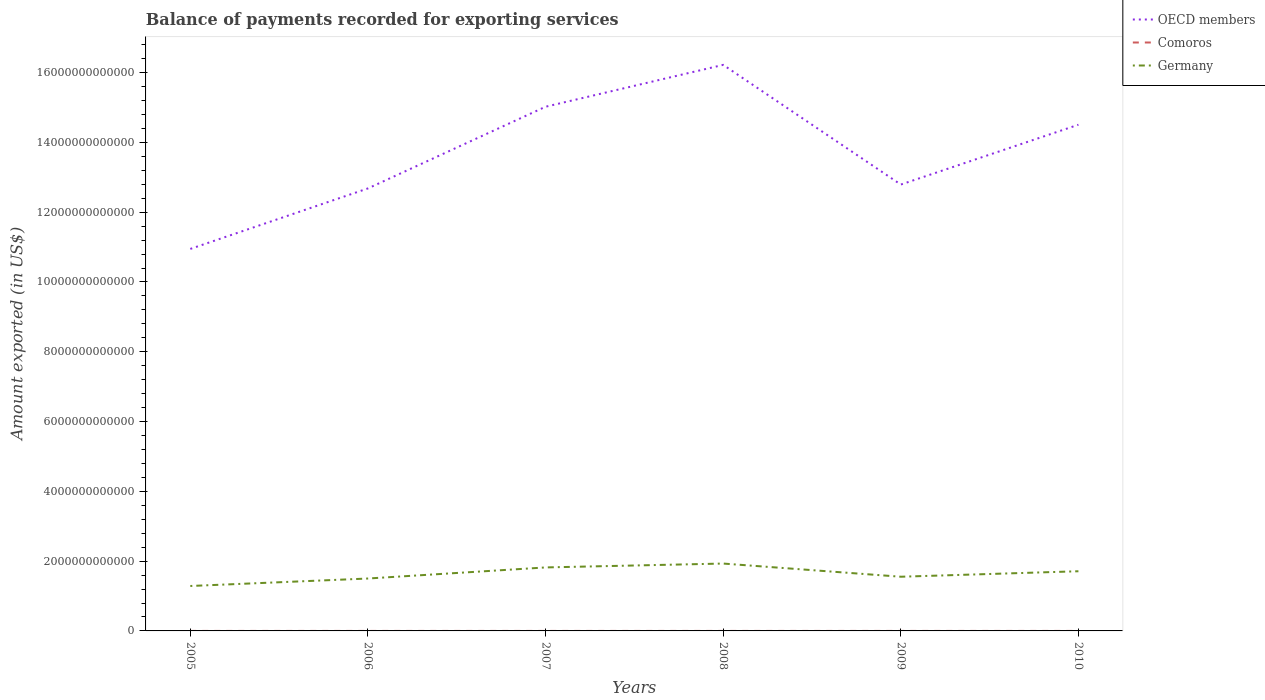How many different coloured lines are there?
Keep it short and to the point. 3. Across all years, what is the maximum amount exported in Comoros?
Offer a terse response. 5.95e+07. What is the total amount exported in Comoros in the graph?
Provide a short and direct response. -1.62e+07. What is the difference between the highest and the second highest amount exported in Comoros?
Your response must be concise. 3.11e+07. Is the amount exported in OECD members strictly greater than the amount exported in Comoros over the years?
Provide a succinct answer. No. How many lines are there?
Provide a short and direct response. 3. How many years are there in the graph?
Give a very brief answer. 6. What is the difference between two consecutive major ticks on the Y-axis?
Provide a succinct answer. 2.00e+12. Does the graph contain any zero values?
Keep it short and to the point. No. Does the graph contain grids?
Your answer should be compact. No. What is the title of the graph?
Provide a short and direct response. Balance of payments recorded for exporting services. Does "Kazakhstan" appear as one of the legend labels in the graph?
Provide a succinct answer. No. What is the label or title of the X-axis?
Your response must be concise. Years. What is the label or title of the Y-axis?
Offer a terse response. Amount exported (in US$). What is the Amount exported (in US$) of OECD members in 2005?
Your response must be concise. 1.09e+13. What is the Amount exported (in US$) in Comoros in 2005?
Ensure brevity in your answer.  5.95e+07. What is the Amount exported (in US$) in Germany in 2005?
Provide a succinct answer. 1.29e+12. What is the Amount exported (in US$) of OECD members in 2006?
Provide a short and direct response. 1.27e+13. What is the Amount exported (in US$) in Comoros in 2006?
Give a very brief answer. 6.35e+07. What is the Amount exported (in US$) in Germany in 2006?
Your answer should be compact. 1.50e+12. What is the Amount exported (in US$) in OECD members in 2007?
Make the answer very short. 1.50e+13. What is the Amount exported (in US$) in Comoros in 2007?
Give a very brief answer. 7.68e+07. What is the Amount exported (in US$) of Germany in 2007?
Offer a terse response. 1.82e+12. What is the Amount exported (in US$) of OECD members in 2008?
Offer a terse response. 1.62e+13. What is the Amount exported (in US$) of Comoros in 2008?
Your answer should be compact. 7.97e+07. What is the Amount exported (in US$) in Germany in 2008?
Give a very brief answer. 1.93e+12. What is the Amount exported (in US$) in OECD members in 2009?
Keep it short and to the point. 1.28e+13. What is the Amount exported (in US$) of Comoros in 2009?
Keep it short and to the point. 8.09e+07. What is the Amount exported (in US$) of Germany in 2009?
Give a very brief answer. 1.55e+12. What is the Amount exported (in US$) in OECD members in 2010?
Your answer should be compact. 1.45e+13. What is the Amount exported (in US$) of Comoros in 2010?
Offer a terse response. 9.07e+07. What is the Amount exported (in US$) in Germany in 2010?
Your response must be concise. 1.71e+12. Across all years, what is the maximum Amount exported (in US$) of OECD members?
Ensure brevity in your answer.  1.62e+13. Across all years, what is the maximum Amount exported (in US$) of Comoros?
Your response must be concise. 9.07e+07. Across all years, what is the maximum Amount exported (in US$) in Germany?
Provide a succinct answer. 1.93e+12. Across all years, what is the minimum Amount exported (in US$) in OECD members?
Provide a succinct answer. 1.09e+13. Across all years, what is the minimum Amount exported (in US$) in Comoros?
Provide a short and direct response. 5.95e+07. Across all years, what is the minimum Amount exported (in US$) in Germany?
Provide a short and direct response. 1.29e+12. What is the total Amount exported (in US$) in OECD members in the graph?
Your answer should be very brief. 8.22e+13. What is the total Amount exported (in US$) in Comoros in the graph?
Offer a very short reply. 4.51e+08. What is the total Amount exported (in US$) in Germany in the graph?
Provide a succinct answer. 9.80e+12. What is the difference between the Amount exported (in US$) in OECD members in 2005 and that in 2006?
Your answer should be very brief. -1.73e+12. What is the difference between the Amount exported (in US$) in Comoros in 2005 and that in 2006?
Offer a very short reply. -3.95e+06. What is the difference between the Amount exported (in US$) in Germany in 2005 and that in 2006?
Your answer should be very brief. -2.14e+11. What is the difference between the Amount exported (in US$) of OECD members in 2005 and that in 2007?
Offer a very short reply. -4.07e+12. What is the difference between the Amount exported (in US$) of Comoros in 2005 and that in 2007?
Give a very brief answer. -1.73e+07. What is the difference between the Amount exported (in US$) in Germany in 2005 and that in 2007?
Offer a very short reply. -5.32e+11. What is the difference between the Amount exported (in US$) of OECD members in 2005 and that in 2008?
Your answer should be very brief. -5.27e+12. What is the difference between the Amount exported (in US$) in Comoros in 2005 and that in 2008?
Offer a very short reply. -2.01e+07. What is the difference between the Amount exported (in US$) of Germany in 2005 and that in 2008?
Give a very brief answer. -6.43e+11. What is the difference between the Amount exported (in US$) in OECD members in 2005 and that in 2009?
Keep it short and to the point. -1.84e+12. What is the difference between the Amount exported (in US$) of Comoros in 2005 and that in 2009?
Ensure brevity in your answer.  -2.13e+07. What is the difference between the Amount exported (in US$) of Germany in 2005 and that in 2009?
Offer a terse response. -2.65e+11. What is the difference between the Amount exported (in US$) in OECD members in 2005 and that in 2010?
Make the answer very short. -3.56e+12. What is the difference between the Amount exported (in US$) of Comoros in 2005 and that in 2010?
Your response must be concise. -3.11e+07. What is the difference between the Amount exported (in US$) of Germany in 2005 and that in 2010?
Your answer should be very brief. -4.22e+11. What is the difference between the Amount exported (in US$) in OECD members in 2006 and that in 2007?
Give a very brief answer. -2.34e+12. What is the difference between the Amount exported (in US$) of Comoros in 2006 and that in 2007?
Offer a terse response. -1.33e+07. What is the difference between the Amount exported (in US$) of Germany in 2006 and that in 2007?
Give a very brief answer. -3.18e+11. What is the difference between the Amount exported (in US$) of OECD members in 2006 and that in 2008?
Offer a very short reply. -3.54e+12. What is the difference between the Amount exported (in US$) in Comoros in 2006 and that in 2008?
Offer a terse response. -1.62e+07. What is the difference between the Amount exported (in US$) of Germany in 2006 and that in 2008?
Keep it short and to the point. -4.29e+11. What is the difference between the Amount exported (in US$) in OECD members in 2006 and that in 2009?
Provide a succinct answer. -1.11e+11. What is the difference between the Amount exported (in US$) of Comoros in 2006 and that in 2009?
Your response must be concise. -1.74e+07. What is the difference between the Amount exported (in US$) in Germany in 2006 and that in 2009?
Keep it short and to the point. -5.12e+1. What is the difference between the Amount exported (in US$) of OECD members in 2006 and that in 2010?
Your response must be concise. -1.83e+12. What is the difference between the Amount exported (in US$) in Comoros in 2006 and that in 2010?
Provide a short and direct response. -2.72e+07. What is the difference between the Amount exported (in US$) in Germany in 2006 and that in 2010?
Keep it short and to the point. -2.08e+11. What is the difference between the Amount exported (in US$) of OECD members in 2007 and that in 2008?
Your answer should be very brief. -1.20e+12. What is the difference between the Amount exported (in US$) in Comoros in 2007 and that in 2008?
Offer a terse response. -2.87e+06. What is the difference between the Amount exported (in US$) of Germany in 2007 and that in 2008?
Make the answer very short. -1.11e+11. What is the difference between the Amount exported (in US$) of OECD members in 2007 and that in 2009?
Your answer should be compact. 2.23e+12. What is the difference between the Amount exported (in US$) of Comoros in 2007 and that in 2009?
Give a very brief answer. -4.09e+06. What is the difference between the Amount exported (in US$) of Germany in 2007 and that in 2009?
Your answer should be compact. 2.66e+11. What is the difference between the Amount exported (in US$) of OECD members in 2007 and that in 2010?
Make the answer very short. 5.16e+11. What is the difference between the Amount exported (in US$) in Comoros in 2007 and that in 2010?
Provide a succinct answer. -1.39e+07. What is the difference between the Amount exported (in US$) of Germany in 2007 and that in 2010?
Provide a short and direct response. 1.09e+11. What is the difference between the Amount exported (in US$) of OECD members in 2008 and that in 2009?
Ensure brevity in your answer.  3.43e+12. What is the difference between the Amount exported (in US$) in Comoros in 2008 and that in 2009?
Keep it short and to the point. -1.21e+06. What is the difference between the Amount exported (in US$) of Germany in 2008 and that in 2009?
Offer a very short reply. 3.78e+11. What is the difference between the Amount exported (in US$) of OECD members in 2008 and that in 2010?
Provide a short and direct response. 1.72e+12. What is the difference between the Amount exported (in US$) in Comoros in 2008 and that in 2010?
Offer a very short reply. -1.10e+07. What is the difference between the Amount exported (in US$) in Germany in 2008 and that in 2010?
Ensure brevity in your answer.  2.20e+11. What is the difference between the Amount exported (in US$) of OECD members in 2009 and that in 2010?
Provide a short and direct response. -1.71e+12. What is the difference between the Amount exported (in US$) of Comoros in 2009 and that in 2010?
Your answer should be very brief. -9.77e+06. What is the difference between the Amount exported (in US$) of Germany in 2009 and that in 2010?
Your response must be concise. -1.57e+11. What is the difference between the Amount exported (in US$) in OECD members in 2005 and the Amount exported (in US$) in Comoros in 2006?
Your response must be concise. 1.09e+13. What is the difference between the Amount exported (in US$) in OECD members in 2005 and the Amount exported (in US$) in Germany in 2006?
Provide a succinct answer. 9.45e+12. What is the difference between the Amount exported (in US$) in Comoros in 2005 and the Amount exported (in US$) in Germany in 2006?
Keep it short and to the point. -1.50e+12. What is the difference between the Amount exported (in US$) in OECD members in 2005 and the Amount exported (in US$) in Comoros in 2007?
Provide a short and direct response. 1.09e+13. What is the difference between the Amount exported (in US$) of OECD members in 2005 and the Amount exported (in US$) of Germany in 2007?
Your answer should be very brief. 9.13e+12. What is the difference between the Amount exported (in US$) of Comoros in 2005 and the Amount exported (in US$) of Germany in 2007?
Keep it short and to the point. -1.82e+12. What is the difference between the Amount exported (in US$) in OECD members in 2005 and the Amount exported (in US$) in Comoros in 2008?
Make the answer very short. 1.09e+13. What is the difference between the Amount exported (in US$) in OECD members in 2005 and the Amount exported (in US$) in Germany in 2008?
Offer a very short reply. 9.02e+12. What is the difference between the Amount exported (in US$) of Comoros in 2005 and the Amount exported (in US$) of Germany in 2008?
Keep it short and to the point. -1.93e+12. What is the difference between the Amount exported (in US$) of OECD members in 2005 and the Amount exported (in US$) of Comoros in 2009?
Provide a succinct answer. 1.09e+13. What is the difference between the Amount exported (in US$) of OECD members in 2005 and the Amount exported (in US$) of Germany in 2009?
Ensure brevity in your answer.  9.39e+12. What is the difference between the Amount exported (in US$) of Comoros in 2005 and the Amount exported (in US$) of Germany in 2009?
Keep it short and to the point. -1.55e+12. What is the difference between the Amount exported (in US$) of OECD members in 2005 and the Amount exported (in US$) of Comoros in 2010?
Ensure brevity in your answer.  1.09e+13. What is the difference between the Amount exported (in US$) of OECD members in 2005 and the Amount exported (in US$) of Germany in 2010?
Your answer should be compact. 9.24e+12. What is the difference between the Amount exported (in US$) in Comoros in 2005 and the Amount exported (in US$) in Germany in 2010?
Offer a very short reply. -1.71e+12. What is the difference between the Amount exported (in US$) of OECD members in 2006 and the Amount exported (in US$) of Comoros in 2007?
Keep it short and to the point. 1.27e+13. What is the difference between the Amount exported (in US$) of OECD members in 2006 and the Amount exported (in US$) of Germany in 2007?
Your answer should be compact. 1.09e+13. What is the difference between the Amount exported (in US$) in Comoros in 2006 and the Amount exported (in US$) in Germany in 2007?
Give a very brief answer. -1.82e+12. What is the difference between the Amount exported (in US$) of OECD members in 2006 and the Amount exported (in US$) of Comoros in 2008?
Your answer should be compact. 1.27e+13. What is the difference between the Amount exported (in US$) of OECD members in 2006 and the Amount exported (in US$) of Germany in 2008?
Keep it short and to the point. 1.08e+13. What is the difference between the Amount exported (in US$) of Comoros in 2006 and the Amount exported (in US$) of Germany in 2008?
Your answer should be very brief. -1.93e+12. What is the difference between the Amount exported (in US$) of OECD members in 2006 and the Amount exported (in US$) of Comoros in 2009?
Give a very brief answer. 1.27e+13. What is the difference between the Amount exported (in US$) in OECD members in 2006 and the Amount exported (in US$) in Germany in 2009?
Make the answer very short. 1.11e+13. What is the difference between the Amount exported (in US$) in Comoros in 2006 and the Amount exported (in US$) in Germany in 2009?
Ensure brevity in your answer.  -1.55e+12. What is the difference between the Amount exported (in US$) of OECD members in 2006 and the Amount exported (in US$) of Comoros in 2010?
Your response must be concise. 1.27e+13. What is the difference between the Amount exported (in US$) of OECD members in 2006 and the Amount exported (in US$) of Germany in 2010?
Ensure brevity in your answer.  1.10e+13. What is the difference between the Amount exported (in US$) of Comoros in 2006 and the Amount exported (in US$) of Germany in 2010?
Provide a short and direct response. -1.71e+12. What is the difference between the Amount exported (in US$) of OECD members in 2007 and the Amount exported (in US$) of Comoros in 2008?
Offer a very short reply. 1.50e+13. What is the difference between the Amount exported (in US$) of OECD members in 2007 and the Amount exported (in US$) of Germany in 2008?
Provide a succinct answer. 1.31e+13. What is the difference between the Amount exported (in US$) of Comoros in 2007 and the Amount exported (in US$) of Germany in 2008?
Offer a very short reply. -1.93e+12. What is the difference between the Amount exported (in US$) in OECD members in 2007 and the Amount exported (in US$) in Comoros in 2009?
Make the answer very short. 1.50e+13. What is the difference between the Amount exported (in US$) of OECD members in 2007 and the Amount exported (in US$) of Germany in 2009?
Make the answer very short. 1.35e+13. What is the difference between the Amount exported (in US$) in Comoros in 2007 and the Amount exported (in US$) in Germany in 2009?
Give a very brief answer. -1.55e+12. What is the difference between the Amount exported (in US$) in OECD members in 2007 and the Amount exported (in US$) in Comoros in 2010?
Make the answer very short. 1.50e+13. What is the difference between the Amount exported (in US$) in OECD members in 2007 and the Amount exported (in US$) in Germany in 2010?
Give a very brief answer. 1.33e+13. What is the difference between the Amount exported (in US$) in Comoros in 2007 and the Amount exported (in US$) in Germany in 2010?
Make the answer very short. -1.71e+12. What is the difference between the Amount exported (in US$) in OECD members in 2008 and the Amount exported (in US$) in Comoros in 2009?
Keep it short and to the point. 1.62e+13. What is the difference between the Amount exported (in US$) in OECD members in 2008 and the Amount exported (in US$) in Germany in 2009?
Offer a terse response. 1.47e+13. What is the difference between the Amount exported (in US$) of Comoros in 2008 and the Amount exported (in US$) of Germany in 2009?
Offer a terse response. -1.55e+12. What is the difference between the Amount exported (in US$) in OECD members in 2008 and the Amount exported (in US$) in Comoros in 2010?
Make the answer very short. 1.62e+13. What is the difference between the Amount exported (in US$) in OECD members in 2008 and the Amount exported (in US$) in Germany in 2010?
Make the answer very short. 1.45e+13. What is the difference between the Amount exported (in US$) of Comoros in 2008 and the Amount exported (in US$) of Germany in 2010?
Your answer should be very brief. -1.71e+12. What is the difference between the Amount exported (in US$) of OECD members in 2009 and the Amount exported (in US$) of Comoros in 2010?
Your answer should be very brief. 1.28e+13. What is the difference between the Amount exported (in US$) of OECD members in 2009 and the Amount exported (in US$) of Germany in 2010?
Offer a very short reply. 1.11e+13. What is the difference between the Amount exported (in US$) in Comoros in 2009 and the Amount exported (in US$) in Germany in 2010?
Give a very brief answer. -1.71e+12. What is the average Amount exported (in US$) in OECD members per year?
Your response must be concise. 1.37e+13. What is the average Amount exported (in US$) of Comoros per year?
Offer a very short reply. 7.52e+07. What is the average Amount exported (in US$) in Germany per year?
Keep it short and to the point. 1.63e+12. In the year 2005, what is the difference between the Amount exported (in US$) in OECD members and Amount exported (in US$) in Comoros?
Your response must be concise. 1.09e+13. In the year 2005, what is the difference between the Amount exported (in US$) in OECD members and Amount exported (in US$) in Germany?
Offer a very short reply. 9.66e+12. In the year 2005, what is the difference between the Amount exported (in US$) of Comoros and Amount exported (in US$) of Germany?
Your answer should be compact. -1.29e+12. In the year 2006, what is the difference between the Amount exported (in US$) in OECD members and Amount exported (in US$) in Comoros?
Keep it short and to the point. 1.27e+13. In the year 2006, what is the difference between the Amount exported (in US$) of OECD members and Amount exported (in US$) of Germany?
Your answer should be very brief. 1.12e+13. In the year 2006, what is the difference between the Amount exported (in US$) in Comoros and Amount exported (in US$) in Germany?
Provide a succinct answer. -1.50e+12. In the year 2007, what is the difference between the Amount exported (in US$) of OECD members and Amount exported (in US$) of Comoros?
Provide a succinct answer. 1.50e+13. In the year 2007, what is the difference between the Amount exported (in US$) in OECD members and Amount exported (in US$) in Germany?
Provide a short and direct response. 1.32e+13. In the year 2007, what is the difference between the Amount exported (in US$) of Comoros and Amount exported (in US$) of Germany?
Your answer should be very brief. -1.82e+12. In the year 2008, what is the difference between the Amount exported (in US$) of OECD members and Amount exported (in US$) of Comoros?
Provide a short and direct response. 1.62e+13. In the year 2008, what is the difference between the Amount exported (in US$) of OECD members and Amount exported (in US$) of Germany?
Ensure brevity in your answer.  1.43e+13. In the year 2008, what is the difference between the Amount exported (in US$) of Comoros and Amount exported (in US$) of Germany?
Ensure brevity in your answer.  -1.93e+12. In the year 2009, what is the difference between the Amount exported (in US$) of OECD members and Amount exported (in US$) of Comoros?
Make the answer very short. 1.28e+13. In the year 2009, what is the difference between the Amount exported (in US$) of OECD members and Amount exported (in US$) of Germany?
Provide a short and direct response. 1.12e+13. In the year 2009, what is the difference between the Amount exported (in US$) of Comoros and Amount exported (in US$) of Germany?
Offer a terse response. -1.55e+12. In the year 2010, what is the difference between the Amount exported (in US$) of OECD members and Amount exported (in US$) of Comoros?
Make the answer very short. 1.45e+13. In the year 2010, what is the difference between the Amount exported (in US$) in OECD members and Amount exported (in US$) in Germany?
Your answer should be compact. 1.28e+13. In the year 2010, what is the difference between the Amount exported (in US$) in Comoros and Amount exported (in US$) in Germany?
Your answer should be very brief. -1.71e+12. What is the ratio of the Amount exported (in US$) in OECD members in 2005 to that in 2006?
Offer a terse response. 0.86. What is the ratio of the Amount exported (in US$) of Comoros in 2005 to that in 2006?
Offer a terse response. 0.94. What is the ratio of the Amount exported (in US$) in Germany in 2005 to that in 2006?
Offer a terse response. 0.86. What is the ratio of the Amount exported (in US$) in OECD members in 2005 to that in 2007?
Offer a very short reply. 0.73. What is the ratio of the Amount exported (in US$) of Comoros in 2005 to that in 2007?
Keep it short and to the point. 0.78. What is the ratio of the Amount exported (in US$) of Germany in 2005 to that in 2007?
Provide a short and direct response. 0.71. What is the ratio of the Amount exported (in US$) of OECD members in 2005 to that in 2008?
Provide a succinct answer. 0.67. What is the ratio of the Amount exported (in US$) of Comoros in 2005 to that in 2008?
Keep it short and to the point. 0.75. What is the ratio of the Amount exported (in US$) of Germany in 2005 to that in 2008?
Provide a succinct answer. 0.67. What is the ratio of the Amount exported (in US$) in OECD members in 2005 to that in 2009?
Your answer should be very brief. 0.86. What is the ratio of the Amount exported (in US$) in Comoros in 2005 to that in 2009?
Offer a terse response. 0.74. What is the ratio of the Amount exported (in US$) of Germany in 2005 to that in 2009?
Provide a succinct answer. 0.83. What is the ratio of the Amount exported (in US$) of OECD members in 2005 to that in 2010?
Your answer should be compact. 0.75. What is the ratio of the Amount exported (in US$) in Comoros in 2005 to that in 2010?
Ensure brevity in your answer.  0.66. What is the ratio of the Amount exported (in US$) in Germany in 2005 to that in 2010?
Your response must be concise. 0.75. What is the ratio of the Amount exported (in US$) of OECD members in 2006 to that in 2007?
Offer a terse response. 0.84. What is the ratio of the Amount exported (in US$) in Comoros in 2006 to that in 2007?
Provide a succinct answer. 0.83. What is the ratio of the Amount exported (in US$) in Germany in 2006 to that in 2007?
Provide a short and direct response. 0.83. What is the ratio of the Amount exported (in US$) of OECD members in 2006 to that in 2008?
Offer a very short reply. 0.78. What is the ratio of the Amount exported (in US$) in Comoros in 2006 to that in 2008?
Your answer should be compact. 0.8. What is the ratio of the Amount exported (in US$) in Germany in 2006 to that in 2008?
Your response must be concise. 0.78. What is the ratio of the Amount exported (in US$) of OECD members in 2006 to that in 2009?
Provide a short and direct response. 0.99. What is the ratio of the Amount exported (in US$) of Comoros in 2006 to that in 2009?
Your response must be concise. 0.78. What is the ratio of the Amount exported (in US$) of OECD members in 2006 to that in 2010?
Give a very brief answer. 0.87. What is the ratio of the Amount exported (in US$) in Comoros in 2006 to that in 2010?
Ensure brevity in your answer.  0.7. What is the ratio of the Amount exported (in US$) in Germany in 2006 to that in 2010?
Keep it short and to the point. 0.88. What is the ratio of the Amount exported (in US$) of OECD members in 2007 to that in 2008?
Your answer should be compact. 0.93. What is the ratio of the Amount exported (in US$) of Comoros in 2007 to that in 2008?
Your answer should be compact. 0.96. What is the ratio of the Amount exported (in US$) in Germany in 2007 to that in 2008?
Your answer should be compact. 0.94. What is the ratio of the Amount exported (in US$) in OECD members in 2007 to that in 2009?
Provide a succinct answer. 1.17. What is the ratio of the Amount exported (in US$) in Comoros in 2007 to that in 2009?
Provide a short and direct response. 0.95. What is the ratio of the Amount exported (in US$) of Germany in 2007 to that in 2009?
Keep it short and to the point. 1.17. What is the ratio of the Amount exported (in US$) of OECD members in 2007 to that in 2010?
Your answer should be compact. 1.04. What is the ratio of the Amount exported (in US$) of Comoros in 2007 to that in 2010?
Ensure brevity in your answer.  0.85. What is the ratio of the Amount exported (in US$) in Germany in 2007 to that in 2010?
Offer a terse response. 1.06. What is the ratio of the Amount exported (in US$) in OECD members in 2008 to that in 2009?
Your response must be concise. 1.27. What is the ratio of the Amount exported (in US$) in Comoros in 2008 to that in 2009?
Offer a very short reply. 0.98. What is the ratio of the Amount exported (in US$) of Germany in 2008 to that in 2009?
Offer a very short reply. 1.24. What is the ratio of the Amount exported (in US$) in OECD members in 2008 to that in 2010?
Make the answer very short. 1.12. What is the ratio of the Amount exported (in US$) in Comoros in 2008 to that in 2010?
Provide a succinct answer. 0.88. What is the ratio of the Amount exported (in US$) of Germany in 2008 to that in 2010?
Make the answer very short. 1.13. What is the ratio of the Amount exported (in US$) of OECD members in 2009 to that in 2010?
Your response must be concise. 0.88. What is the ratio of the Amount exported (in US$) of Comoros in 2009 to that in 2010?
Give a very brief answer. 0.89. What is the ratio of the Amount exported (in US$) of Germany in 2009 to that in 2010?
Your response must be concise. 0.91. What is the difference between the highest and the second highest Amount exported (in US$) in OECD members?
Make the answer very short. 1.20e+12. What is the difference between the highest and the second highest Amount exported (in US$) in Comoros?
Offer a terse response. 9.77e+06. What is the difference between the highest and the second highest Amount exported (in US$) of Germany?
Your answer should be very brief. 1.11e+11. What is the difference between the highest and the lowest Amount exported (in US$) in OECD members?
Provide a short and direct response. 5.27e+12. What is the difference between the highest and the lowest Amount exported (in US$) in Comoros?
Offer a terse response. 3.11e+07. What is the difference between the highest and the lowest Amount exported (in US$) in Germany?
Your answer should be very brief. 6.43e+11. 